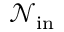<formula> <loc_0><loc_0><loc_500><loc_500>{ \mathcal { N } } _ { i n }</formula> 